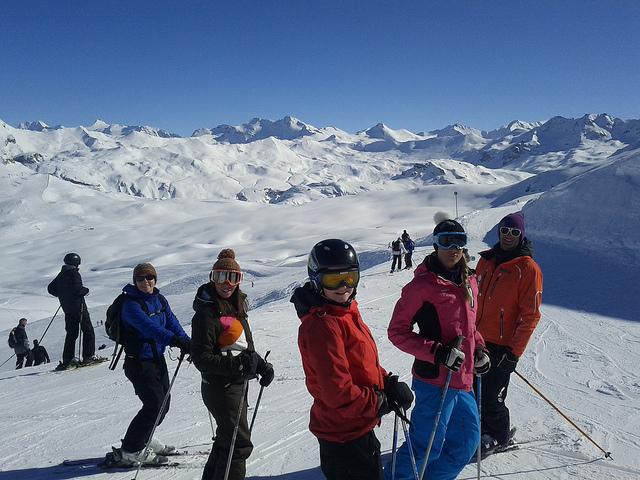How many people are wearing yellow ski pants?
Short answer required. 0. How many people are there?
Concise answer only. 10. Is the landscape rocky or flat?
Short answer required. Rocky. What are in the sky?
Quick response, please. Nothing. Where is the backpack?
Answer briefly. Back. Is this multiple skiers or one single skier?
Keep it brief. Multiple. How many people face the camera?
Answer briefly. 5. How many ski slopes are there?
Write a very short answer. 1. Are all the skiers dressed for the weather?
Keep it brief. Yes. Is this a sunny day?
Answer briefly. Yes. How many people have their eyes covered?
Be succinct. 5. How many people are actually skiing?
Give a very brief answer. 0. 